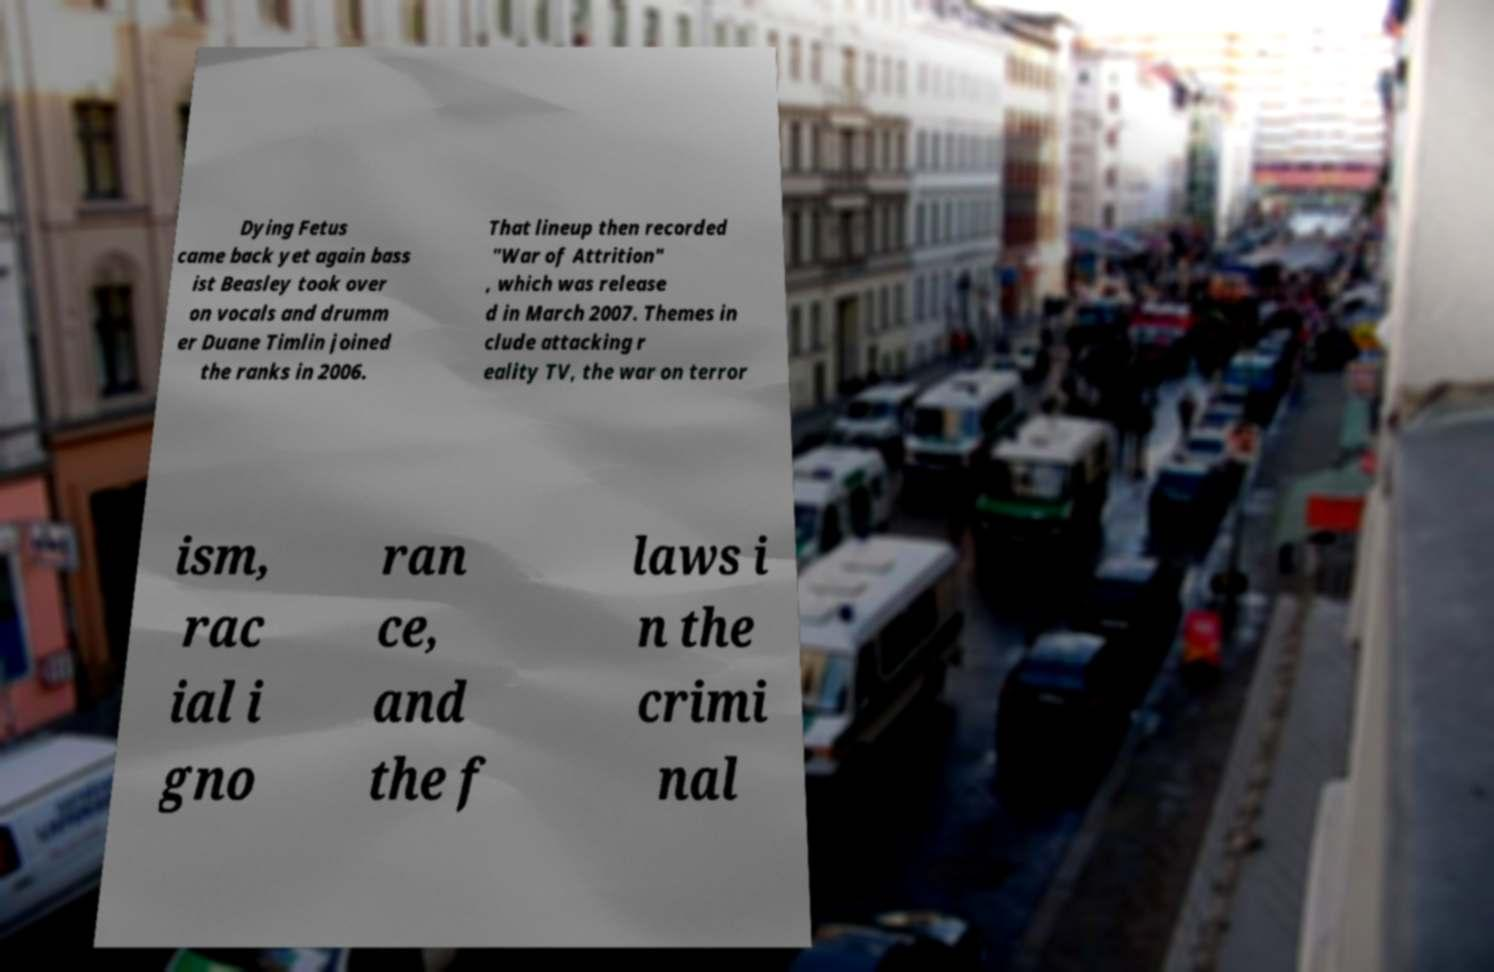There's text embedded in this image that I need extracted. Can you transcribe it verbatim? Dying Fetus came back yet again bass ist Beasley took over on vocals and drumm er Duane Timlin joined the ranks in 2006. That lineup then recorded "War of Attrition" , which was release d in March 2007. Themes in clude attacking r eality TV, the war on terror ism, rac ial i gno ran ce, and the f laws i n the crimi nal 